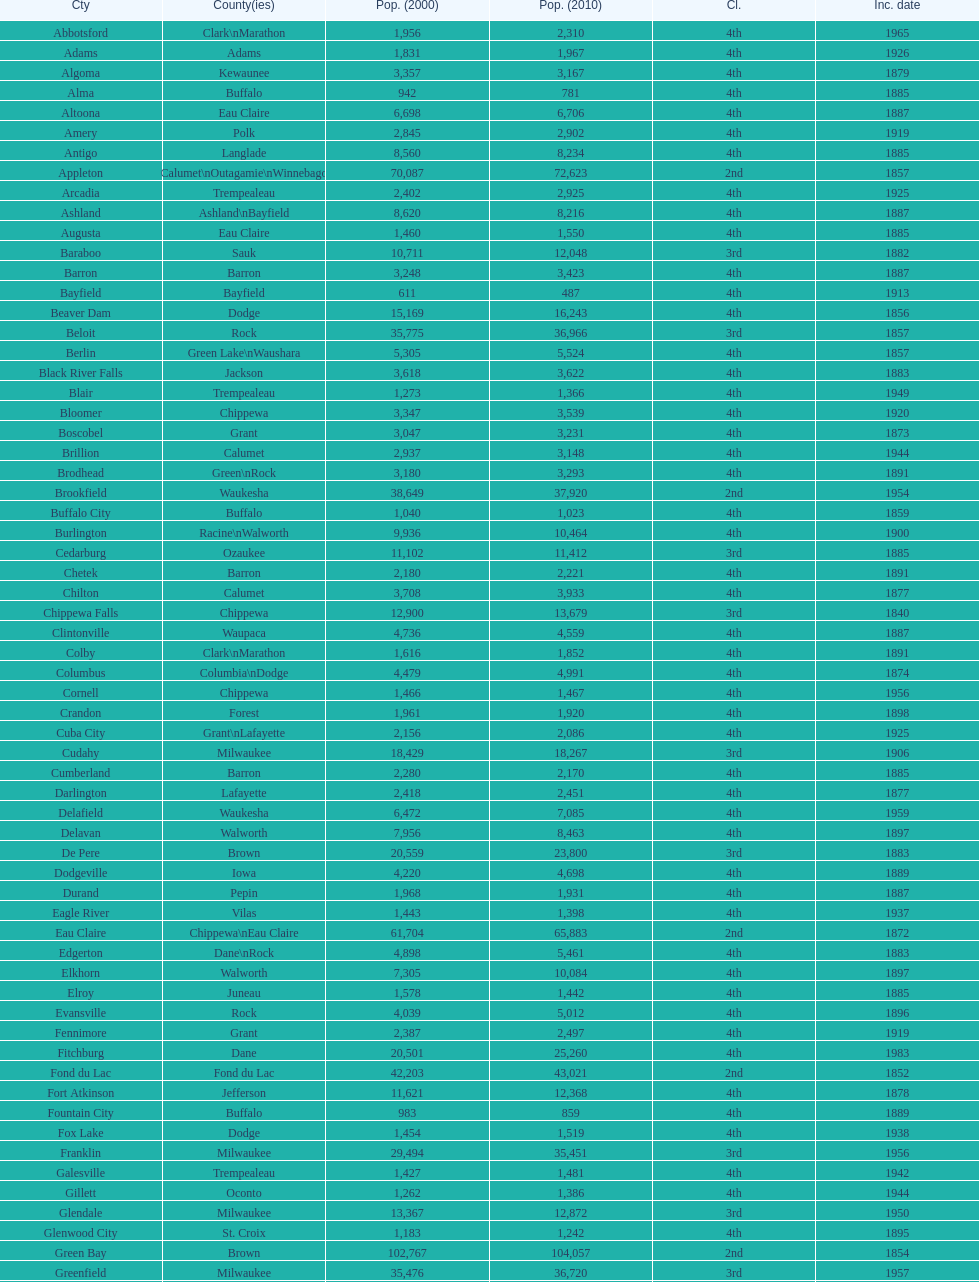How many cities are in wisconsin? 190. 